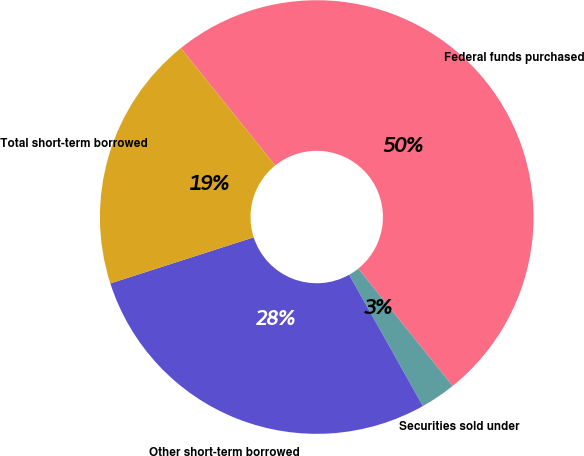<chart> <loc_0><loc_0><loc_500><loc_500><pie_chart><fcel>Federal funds purchased<fcel>Securities sold under<fcel>Other short-term borrowed<fcel>Total short-term borrowed<nl><fcel>50.0%<fcel>2.64%<fcel>28.19%<fcel>19.17%<nl></chart> 